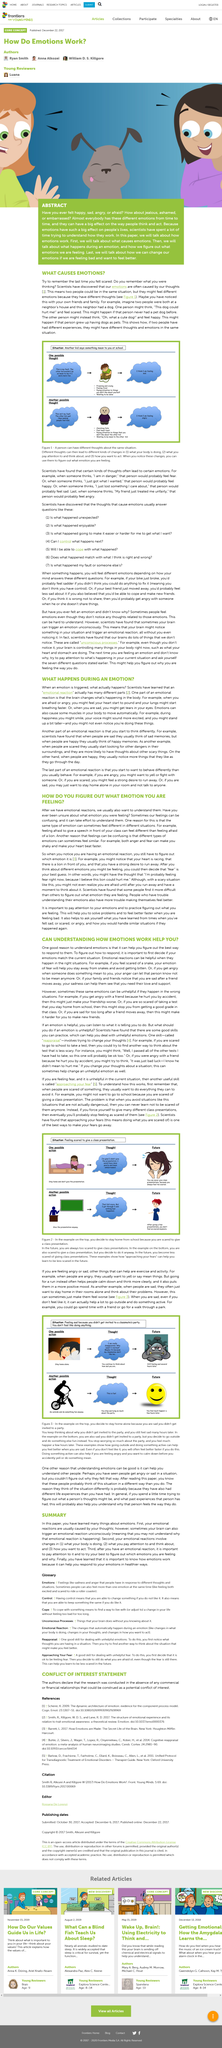Outline some significant characteristics in this image. It is crucial to acknowledge and understand one's emotional reactions after experiencing them, by examining the emotions and the reasons behind them in order to gain insight and control over them. Our feelings can be confusing because the same type of emotion can sometimes feel different in different situations, which can make it difficult to understand and process them. The answer to the title is that thoughts cause stress. Fear is a powerful emotion that is often associated with danger or harm. In the text, the example of fear is given as feeling scared after seeing a snake, which motivates one to stay away from snakes and avoid being bitten. Understanding how emotions work can help you, as the article states and provides examples of fear, anger, and sadness. 